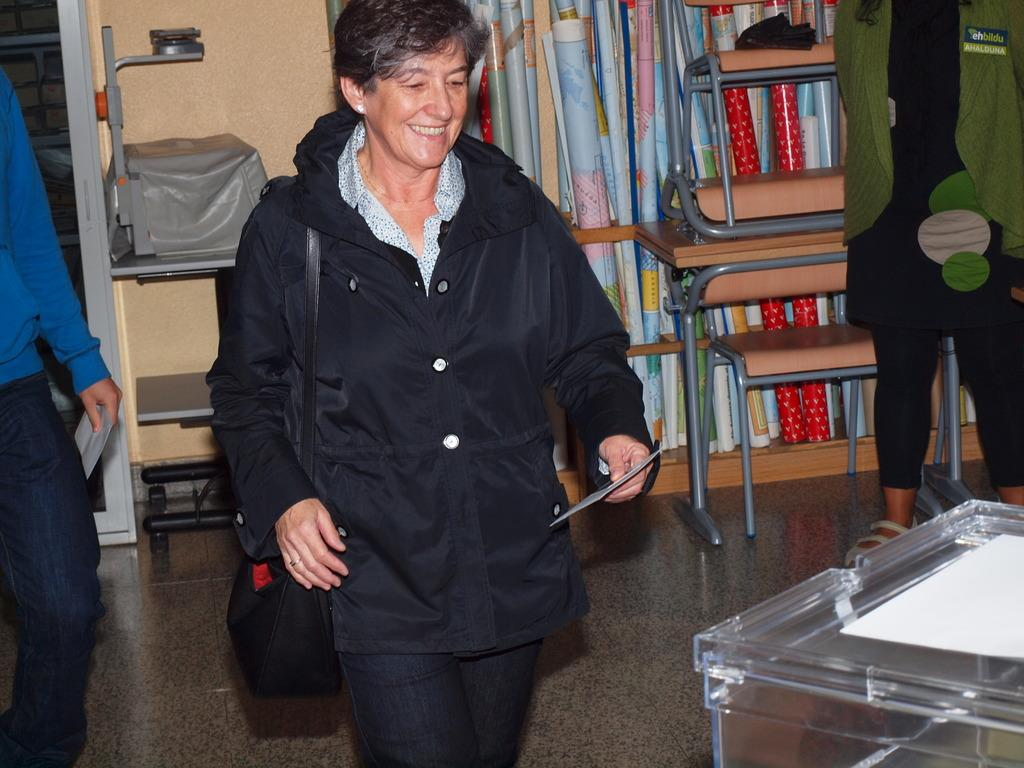What is the woman doing in the image? The woman is standing in the image. Where is the woman standing? The woman is standing on the floor. What expression does the woman have? The woman is smiling. What can be seen on the wall in the image? There are maps visible in the image. What is the background of the image? There is a wall in the image. What else can be seen in the image besides the woman and the wall? There are some objects in the image. What color is the chain that the woman is wearing in the image? There is no chain visible in the image. 